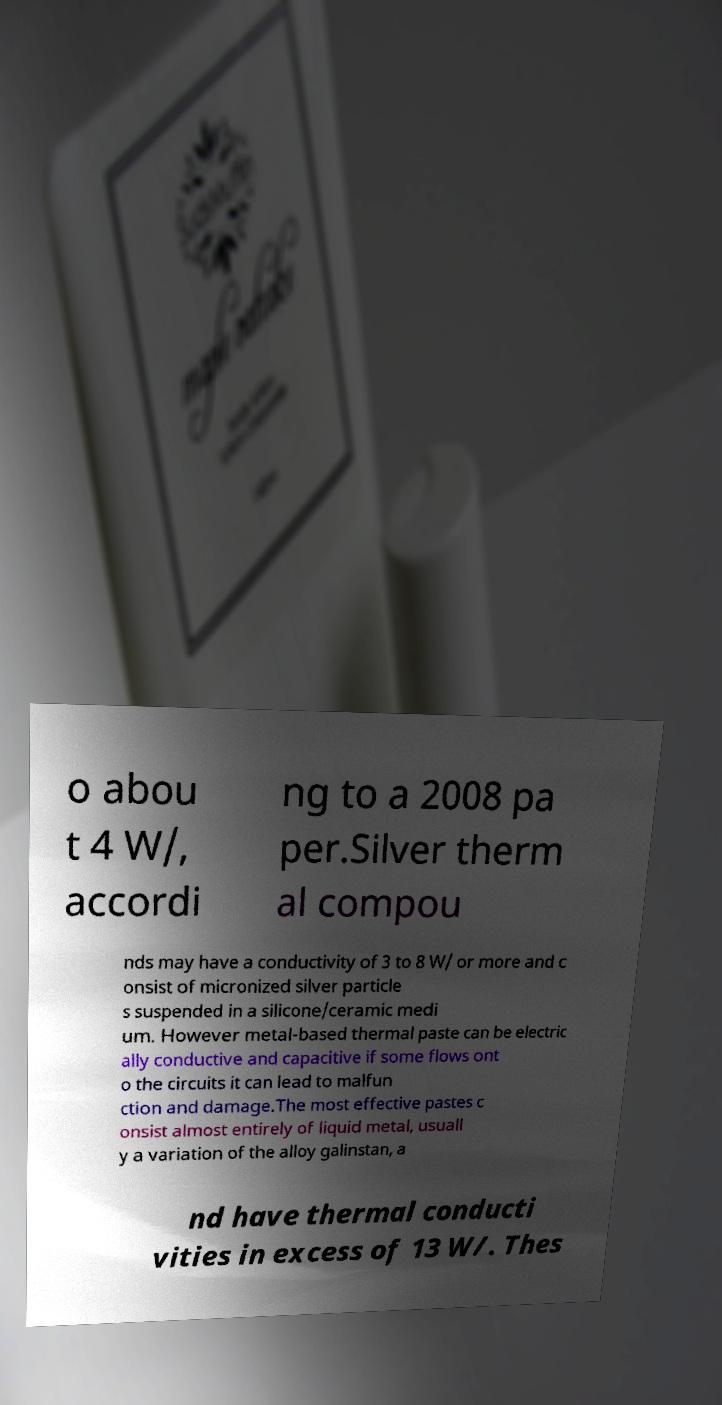There's text embedded in this image that I need extracted. Can you transcribe it verbatim? o abou t 4 W/, accordi ng to a 2008 pa per.Silver therm al compou nds may have a conductivity of 3 to 8 W/ or more and c onsist of micronized silver particle s suspended in a silicone/ceramic medi um. However metal-based thermal paste can be electric ally conductive and capacitive if some flows ont o the circuits it can lead to malfun ction and damage.The most effective pastes c onsist almost entirely of liquid metal, usuall y a variation of the alloy galinstan, a nd have thermal conducti vities in excess of 13 W/. Thes 